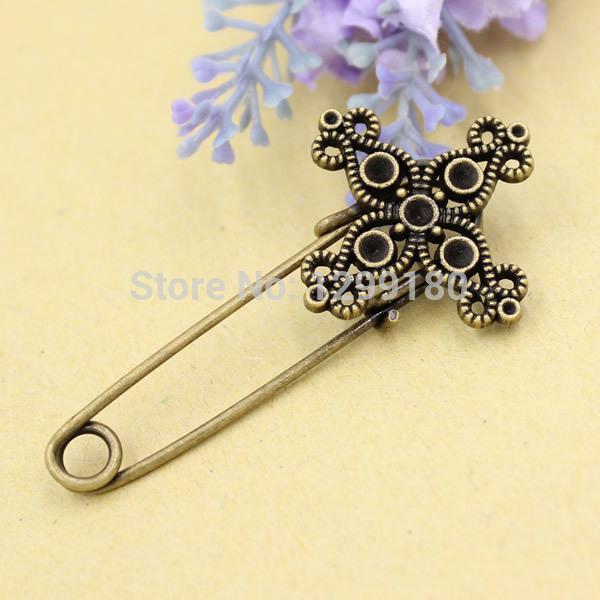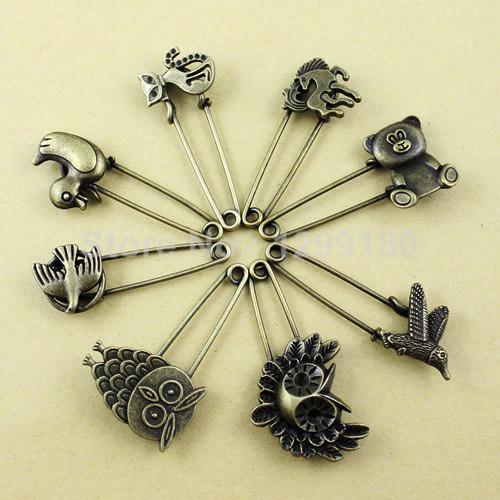The first image is the image on the left, the second image is the image on the right. Analyze the images presented: Is the assertion "An image shows pins arranged like spokes forming a circle." valid? Answer yes or no. Yes. 